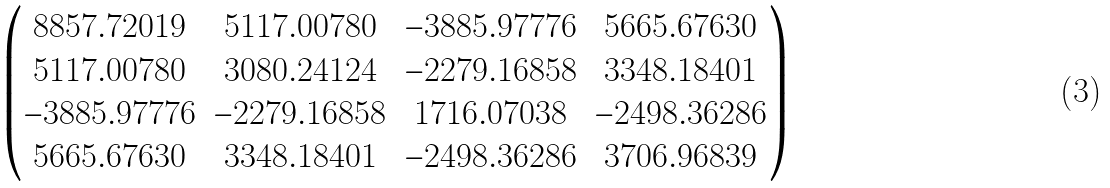<formula> <loc_0><loc_0><loc_500><loc_500>\begin{pmatrix} 8 8 5 7 . 7 2 0 1 9 & 5 1 1 7 . 0 0 7 8 0 & - 3 8 8 5 . 9 7 7 7 6 & 5 6 6 5 . 6 7 6 3 0 \\ 5 1 1 7 . 0 0 7 8 0 & 3 0 8 0 . 2 4 1 2 4 & - 2 2 7 9 . 1 6 8 5 8 & 3 3 4 8 . 1 8 4 0 1 \\ - 3 8 8 5 . 9 7 7 7 6 & - 2 2 7 9 . 1 6 8 5 8 & 1 7 1 6 . 0 7 0 3 8 & - 2 4 9 8 . 3 6 2 8 6 \\ 5 6 6 5 . 6 7 6 3 0 & 3 3 4 8 . 1 8 4 0 1 & - 2 4 9 8 . 3 6 2 8 6 & 3 7 0 6 . 9 6 8 3 9 \end{pmatrix}</formula> 